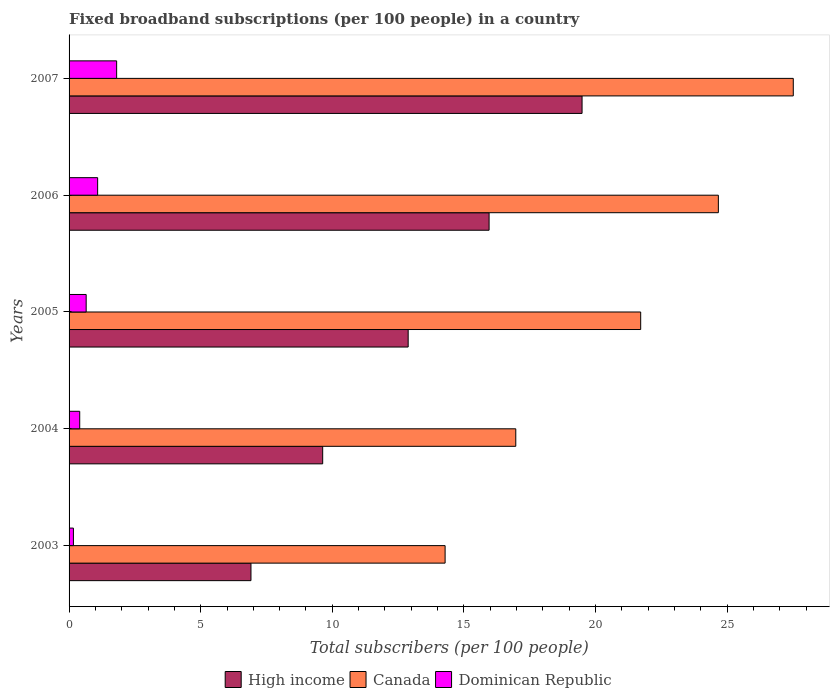How many groups of bars are there?
Provide a short and direct response. 5. Are the number of bars on each tick of the Y-axis equal?
Keep it short and to the point. Yes. What is the label of the 4th group of bars from the top?
Ensure brevity in your answer.  2004. In how many cases, is the number of bars for a given year not equal to the number of legend labels?
Make the answer very short. 0. What is the number of broadband subscriptions in Dominican Republic in 2003?
Provide a short and direct response. 0.17. Across all years, what is the maximum number of broadband subscriptions in Dominican Republic?
Your answer should be very brief. 1.81. Across all years, what is the minimum number of broadband subscriptions in Dominican Republic?
Provide a short and direct response. 0.17. In which year was the number of broadband subscriptions in Canada minimum?
Ensure brevity in your answer.  2003. What is the total number of broadband subscriptions in Canada in the graph?
Offer a very short reply. 105.15. What is the difference between the number of broadband subscriptions in Dominican Republic in 2003 and that in 2006?
Your answer should be compact. -0.92. What is the difference between the number of broadband subscriptions in Canada in 2006 and the number of broadband subscriptions in High income in 2005?
Your answer should be compact. 11.78. What is the average number of broadband subscriptions in Canada per year?
Offer a very short reply. 21.03. In the year 2003, what is the difference between the number of broadband subscriptions in High income and number of broadband subscriptions in Canada?
Your response must be concise. -7.38. In how many years, is the number of broadband subscriptions in High income greater than 19 ?
Give a very brief answer. 1. What is the ratio of the number of broadband subscriptions in Canada in 2003 to that in 2007?
Provide a short and direct response. 0.52. Is the number of broadband subscriptions in Canada in 2003 less than that in 2006?
Give a very brief answer. Yes. Is the difference between the number of broadband subscriptions in High income in 2005 and 2007 greater than the difference between the number of broadband subscriptions in Canada in 2005 and 2007?
Offer a terse response. No. What is the difference between the highest and the second highest number of broadband subscriptions in High income?
Your answer should be very brief. 3.53. What is the difference between the highest and the lowest number of broadband subscriptions in High income?
Keep it short and to the point. 12.58. What does the 2nd bar from the top in 2004 represents?
Provide a short and direct response. Canada. What does the 1st bar from the bottom in 2004 represents?
Provide a short and direct response. High income. Is it the case that in every year, the sum of the number of broadband subscriptions in Canada and number of broadband subscriptions in Dominican Republic is greater than the number of broadband subscriptions in High income?
Ensure brevity in your answer.  Yes. Are all the bars in the graph horizontal?
Your answer should be compact. Yes. How many years are there in the graph?
Your answer should be very brief. 5. What is the difference between two consecutive major ticks on the X-axis?
Offer a very short reply. 5. How many legend labels are there?
Make the answer very short. 3. What is the title of the graph?
Offer a terse response. Fixed broadband subscriptions (per 100 people) in a country. What is the label or title of the X-axis?
Keep it short and to the point. Total subscribers (per 100 people). What is the Total subscribers (per 100 people) of High income in 2003?
Give a very brief answer. 6.91. What is the Total subscribers (per 100 people) in Canada in 2003?
Make the answer very short. 14.29. What is the Total subscribers (per 100 people) in Dominican Republic in 2003?
Keep it short and to the point. 0.17. What is the Total subscribers (per 100 people) in High income in 2004?
Ensure brevity in your answer.  9.63. What is the Total subscribers (per 100 people) of Canada in 2004?
Your answer should be very brief. 16.97. What is the Total subscribers (per 100 people) in Dominican Republic in 2004?
Your answer should be very brief. 0.4. What is the Total subscribers (per 100 people) in High income in 2005?
Ensure brevity in your answer.  12.88. What is the Total subscribers (per 100 people) of Canada in 2005?
Your answer should be very brief. 21.72. What is the Total subscribers (per 100 people) in Dominican Republic in 2005?
Offer a very short reply. 0.65. What is the Total subscribers (per 100 people) of High income in 2006?
Make the answer very short. 15.96. What is the Total subscribers (per 100 people) of Canada in 2006?
Offer a terse response. 24.67. What is the Total subscribers (per 100 people) of Dominican Republic in 2006?
Give a very brief answer. 1.09. What is the Total subscribers (per 100 people) in High income in 2007?
Provide a short and direct response. 19.49. What is the Total subscribers (per 100 people) in Canada in 2007?
Provide a short and direct response. 27.51. What is the Total subscribers (per 100 people) of Dominican Republic in 2007?
Keep it short and to the point. 1.81. Across all years, what is the maximum Total subscribers (per 100 people) of High income?
Make the answer very short. 19.49. Across all years, what is the maximum Total subscribers (per 100 people) in Canada?
Keep it short and to the point. 27.51. Across all years, what is the maximum Total subscribers (per 100 people) of Dominican Republic?
Provide a succinct answer. 1.81. Across all years, what is the minimum Total subscribers (per 100 people) in High income?
Give a very brief answer. 6.91. Across all years, what is the minimum Total subscribers (per 100 people) in Canada?
Ensure brevity in your answer.  14.29. Across all years, what is the minimum Total subscribers (per 100 people) in Dominican Republic?
Keep it short and to the point. 0.17. What is the total Total subscribers (per 100 people) of High income in the graph?
Your answer should be very brief. 64.87. What is the total Total subscribers (per 100 people) of Canada in the graph?
Offer a very short reply. 105.15. What is the total Total subscribers (per 100 people) in Dominican Republic in the graph?
Offer a very short reply. 4.11. What is the difference between the Total subscribers (per 100 people) in High income in 2003 and that in 2004?
Make the answer very short. -2.72. What is the difference between the Total subscribers (per 100 people) of Canada in 2003 and that in 2004?
Provide a succinct answer. -2.69. What is the difference between the Total subscribers (per 100 people) in Dominican Republic in 2003 and that in 2004?
Your response must be concise. -0.24. What is the difference between the Total subscribers (per 100 people) in High income in 2003 and that in 2005?
Offer a terse response. -5.97. What is the difference between the Total subscribers (per 100 people) in Canada in 2003 and that in 2005?
Provide a short and direct response. -7.43. What is the difference between the Total subscribers (per 100 people) in Dominican Republic in 2003 and that in 2005?
Give a very brief answer. -0.48. What is the difference between the Total subscribers (per 100 people) in High income in 2003 and that in 2006?
Ensure brevity in your answer.  -9.05. What is the difference between the Total subscribers (per 100 people) in Canada in 2003 and that in 2006?
Provide a succinct answer. -10.38. What is the difference between the Total subscribers (per 100 people) in Dominican Republic in 2003 and that in 2006?
Ensure brevity in your answer.  -0.92. What is the difference between the Total subscribers (per 100 people) in High income in 2003 and that in 2007?
Make the answer very short. -12.58. What is the difference between the Total subscribers (per 100 people) of Canada in 2003 and that in 2007?
Ensure brevity in your answer.  -13.23. What is the difference between the Total subscribers (per 100 people) of Dominican Republic in 2003 and that in 2007?
Make the answer very short. -1.64. What is the difference between the Total subscribers (per 100 people) of High income in 2004 and that in 2005?
Keep it short and to the point. -3.25. What is the difference between the Total subscribers (per 100 people) of Canada in 2004 and that in 2005?
Ensure brevity in your answer.  -4.75. What is the difference between the Total subscribers (per 100 people) in Dominican Republic in 2004 and that in 2005?
Your response must be concise. -0.24. What is the difference between the Total subscribers (per 100 people) in High income in 2004 and that in 2006?
Keep it short and to the point. -6.32. What is the difference between the Total subscribers (per 100 people) in Canada in 2004 and that in 2006?
Ensure brevity in your answer.  -7.7. What is the difference between the Total subscribers (per 100 people) in Dominican Republic in 2004 and that in 2006?
Make the answer very short. -0.68. What is the difference between the Total subscribers (per 100 people) of High income in 2004 and that in 2007?
Provide a succinct answer. -9.85. What is the difference between the Total subscribers (per 100 people) of Canada in 2004 and that in 2007?
Your response must be concise. -10.54. What is the difference between the Total subscribers (per 100 people) of Dominican Republic in 2004 and that in 2007?
Offer a terse response. -1.4. What is the difference between the Total subscribers (per 100 people) in High income in 2005 and that in 2006?
Make the answer very short. -3.07. What is the difference between the Total subscribers (per 100 people) of Canada in 2005 and that in 2006?
Provide a short and direct response. -2.95. What is the difference between the Total subscribers (per 100 people) of Dominican Republic in 2005 and that in 2006?
Keep it short and to the point. -0.44. What is the difference between the Total subscribers (per 100 people) of High income in 2005 and that in 2007?
Your answer should be very brief. -6.61. What is the difference between the Total subscribers (per 100 people) in Canada in 2005 and that in 2007?
Your answer should be compact. -5.8. What is the difference between the Total subscribers (per 100 people) in Dominican Republic in 2005 and that in 2007?
Offer a terse response. -1.16. What is the difference between the Total subscribers (per 100 people) of High income in 2006 and that in 2007?
Offer a terse response. -3.53. What is the difference between the Total subscribers (per 100 people) of Canada in 2006 and that in 2007?
Provide a short and direct response. -2.85. What is the difference between the Total subscribers (per 100 people) in Dominican Republic in 2006 and that in 2007?
Ensure brevity in your answer.  -0.72. What is the difference between the Total subscribers (per 100 people) of High income in 2003 and the Total subscribers (per 100 people) of Canada in 2004?
Keep it short and to the point. -10.06. What is the difference between the Total subscribers (per 100 people) in High income in 2003 and the Total subscribers (per 100 people) in Dominican Republic in 2004?
Give a very brief answer. 6.51. What is the difference between the Total subscribers (per 100 people) in Canada in 2003 and the Total subscribers (per 100 people) in Dominican Republic in 2004?
Your answer should be compact. 13.88. What is the difference between the Total subscribers (per 100 people) of High income in 2003 and the Total subscribers (per 100 people) of Canada in 2005?
Offer a very short reply. -14.81. What is the difference between the Total subscribers (per 100 people) in High income in 2003 and the Total subscribers (per 100 people) in Dominican Republic in 2005?
Keep it short and to the point. 6.26. What is the difference between the Total subscribers (per 100 people) in Canada in 2003 and the Total subscribers (per 100 people) in Dominican Republic in 2005?
Give a very brief answer. 13.64. What is the difference between the Total subscribers (per 100 people) in High income in 2003 and the Total subscribers (per 100 people) in Canada in 2006?
Provide a short and direct response. -17.76. What is the difference between the Total subscribers (per 100 people) in High income in 2003 and the Total subscribers (per 100 people) in Dominican Republic in 2006?
Your answer should be very brief. 5.82. What is the difference between the Total subscribers (per 100 people) of Canada in 2003 and the Total subscribers (per 100 people) of Dominican Republic in 2006?
Give a very brief answer. 13.2. What is the difference between the Total subscribers (per 100 people) in High income in 2003 and the Total subscribers (per 100 people) in Canada in 2007?
Your answer should be very brief. -20.6. What is the difference between the Total subscribers (per 100 people) in High income in 2003 and the Total subscribers (per 100 people) in Dominican Republic in 2007?
Provide a short and direct response. 5.1. What is the difference between the Total subscribers (per 100 people) in Canada in 2003 and the Total subscribers (per 100 people) in Dominican Republic in 2007?
Give a very brief answer. 12.48. What is the difference between the Total subscribers (per 100 people) of High income in 2004 and the Total subscribers (per 100 people) of Canada in 2005?
Your answer should be very brief. -12.08. What is the difference between the Total subscribers (per 100 people) of High income in 2004 and the Total subscribers (per 100 people) of Dominican Republic in 2005?
Keep it short and to the point. 8.99. What is the difference between the Total subscribers (per 100 people) in Canada in 2004 and the Total subscribers (per 100 people) in Dominican Republic in 2005?
Offer a very short reply. 16.32. What is the difference between the Total subscribers (per 100 people) of High income in 2004 and the Total subscribers (per 100 people) of Canada in 2006?
Offer a very short reply. -15.03. What is the difference between the Total subscribers (per 100 people) of High income in 2004 and the Total subscribers (per 100 people) of Dominican Republic in 2006?
Offer a very short reply. 8.55. What is the difference between the Total subscribers (per 100 people) of Canada in 2004 and the Total subscribers (per 100 people) of Dominican Republic in 2006?
Make the answer very short. 15.89. What is the difference between the Total subscribers (per 100 people) in High income in 2004 and the Total subscribers (per 100 people) in Canada in 2007?
Ensure brevity in your answer.  -17.88. What is the difference between the Total subscribers (per 100 people) of High income in 2004 and the Total subscribers (per 100 people) of Dominican Republic in 2007?
Your answer should be compact. 7.83. What is the difference between the Total subscribers (per 100 people) in Canada in 2004 and the Total subscribers (per 100 people) in Dominican Republic in 2007?
Give a very brief answer. 15.16. What is the difference between the Total subscribers (per 100 people) of High income in 2005 and the Total subscribers (per 100 people) of Canada in 2006?
Offer a very short reply. -11.78. What is the difference between the Total subscribers (per 100 people) of High income in 2005 and the Total subscribers (per 100 people) of Dominican Republic in 2006?
Your response must be concise. 11.8. What is the difference between the Total subscribers (per 100 people) in Canada in 2005 and the Total subscribers (per 100 people) in Dominican Republic in 2006?
Your answer should be compact. 20.63. What is the difference between the Total subscribers (per 100 people) in High income in 2005 and the Total subscribers (per 100 people) in Canada in 2007?
Ensure brevity in your answer.  -14.63. What is the difference between the Total subscribers (per 100 people) in High income in 2005 and the Total subscribers (per 100 people) in Dominican Republic in 2007?
Offer a very short reply. 11.08. What is the difference between the Total subscribers (per 100 people) of Canada in 2005 and the Total subscribers (per 100 people) of Dominican Republic in 2007?
Offer a terse response. 19.91. What is the difference between the Total subscribers (per 100 people) in High income in 2006 and the Total subscribers (per 100 people) in Canada in 2007?
Make the answer very short. -11.56. What is the difference between the Total subscribers (per 100 people) in High income in 2006 and the Total subscribers (per 100 people) in Dominican Republic in 2007?
Make the answer very short. 14.15. What is the difference between the Total subscribers (per 100 people) of Canada in 2006 and the Total subscribers (per 100 people) of Dominican Republic in 2007?
Make the answer very short. 22.86. What is the average Total subscribers (per 100 people) in High income per year?
Your answer should be very brief. 12.97. What is the average Total subscribers (per 100 people) of Canada per year?
Provide a succinct answer. 21.03. What is the average Total subscribers (per 100 people) in Dominican Republic per year?
Your response must be concise. 0.82. In the year 2003, what is the difference between the Total subscribers (per 100 people) in High income and Total subscribers (per 100 people) in Canada?
Make the answer very short. -7.38. In the year 2003, what is the difference between the Total subscribers (per 100 people) in High income and Total subscribers (per 100 people) in Dominican Republic?
Make the answer very short. 6.74. In the year 2003, what is the difference between the Total subscribers (per 100 people) of Canada and Total subscribers (per 100 people) of Dominican Republic?
Give a very brief answer. 14.12. In the year 2004, what is the difference between the Total subscribers (per 100 people) of High income and Total subscribers (per 100 people) of Canada?
Provide a succinct answer. -7.34. In the year 2004, what is the difference between the Total subscribers (per 100 people) of High income and Total subscribers (per 100 people) of Dominican Republic?
Offer a very short reply. 9.23. In the year 2004, what is the difference between the Total subscribers (per 100 people) in Canada and Total subscribers (per 100 people) in Dominican Republic?
Provide a succinct answer. 16.57. In the year 2005, what is the difference between the Total subscribers (per 100 people) in High income and Total subscribers (per 100 people) in Canada?
Provide a succinct answer. -8.83. In the year 2005, what is the difference between the Total subscribers (per 100 people) of High income and Total subscribers (per 100 people) of Dominican Republic?
Give a very brief answer. 12.23. In the year 2005, what is the difference between the Total subscribers (per 100 people) in Canada and Total subscribers (per 100 people) in Dominican Republic?
Your answer should be compact. 21.07. In the year 2006, what is the difference between the Total subscribers (per 100 people) in High income and Total subscribers (per 100 people) in Canada?
Give a very brief answer. -8.71. In the year 2006, what is the difference between the Total subscribers (per 100 people) of High income and Total subscribers (per 100 people) of Dominican Republic?
Your answer should be compact. 14.87. In the year 2006, what is the difference between the Total subscribers (per 100 people) of Canada and Total subscribers (per 100 people) of Dominican Republic?
Make the answer very short. 23.58. In the year 2007, what is the difference between the Total subscribers (per 100 people) of High income and Total subscribers (per 100 people) of Canada?
Make the answer very short. -8.02. In the year 2007, what is the difference between the Total subscribers (per 100 people) of High income and Total subscribers (per 100 people) of Dominican Republic?
Your answer should be compact. 17.68. In the year 2007, what is the difference between the Total subscribers (per 100 people) in Canada and Total subscribers (per 100 people) in Dominican Republic?
Your answer should be compact. 25.71. What is the ratio of the Total subscribers (per 100 people) in High income in 2003 to that in 2004?
Offer a very short reply. 0.72. What is the ratio of the Total subscribers (per 100 people) in Canada in 2003 to that in 2004?
Provide a succinct answer. 0.84. What is the ratio of the Total subscribers (per 100 people) of Dominican Republic in 2003 to that in 2004?
Ensure brevity in your answer.  0.41. What is the ratio of the Total subscribers (per 100 people) in High income in 2003 to that in 2005?
Your answer should be compact. 0.54. What is the ratio of the Total subscribers (per 100 people) in Canada in 2003 to that in 2005?
Your answer should be very brief. 0.66. What is the ratio of the Total subscribers (per 100 people) in Dominican Republic in 2003 to that in 2005?
Your answer should be very brief. 0.25. What is the ratio of the Total subscribers (per 100 people) of High income in 2003 to that in 2006?
Ensure brevity in your answer.  0.43. What is the ratio of the Total subscribers (per 100 people) of Canada in 2003 to that in 2006?
Your answer should be very brief. 0.58. What is the ratio of the Total subscribers (per 100 people) in Dominican Republic in 2003 to that in 2006?
Ensure brevity in your answer.  0.15. What is the ratio of the Total subscribers (per 100 people) of High income in 2003 to that in 2007?
Provide a short and direct response. 0.35. What is the ratio of the Total subscribers (per 100 people) of Canada in 2003 to that in 2007?
Give a very brief answer. 0.52. What is the ratio of the Total subscribers (per 100 people) of Dominican Republic in 2003 to that in 2007?
Ensure brevity in your answer.  0.09. What is the ratio of the Total subscribers (per 100 people) in High income in 2004 to that in 2005?
Your answer should be very brief. 0.75. What is the ratio of the Total subscribers (per 100 people) in Canada in 2004 to that in 2005?
Provide a short and direct response. 0.78. What is the ratio of the Total subscribers (per 100 people) of Dominican Republic in 2004 to that in 2005?
Provide a succinct answer. 0.62. What is the ratio of the Total subscribers (per 100 people) in High income in 2004 to that in 2006?
Make the answer very short. 0.6. What is the ratio of the Total subscribers (per 100 people) of Canada in 2004 to that in 2006?
Provide a succinct answer. 0.69. What is the ratio of the Total subscribers (per 100 people) of Dominican Republic in 2004 to that in 2006?
Your answer should be compact. 0.37. What is the ratio of the Total subscribers (per 100 people) in High income in 2004 to that in 2007?
Your answer should be compact. 0.49. What is the ratio of the Total subscribers (per 100 people) of Canada in 2004 to that in 2007?
Your answer should be very brief. 0.62. What is the ratio of the Total subscribers (per 100 people) of Dominican Republic in 2004 to that in 2007?
Your answer should be compact. 0.22. What is the ratio of the Total subscribers (per 100 people) of High income in 2005 to that in 2006?
Give a very brief answer. 0.81. What is the ratio of the Total subscribers (per 100 people) in Canada in 2005 to that in 2006?
Offer a terse response. 0.88. What is the ratio of the Total subscribers (per 100 people) of Dominican Republic in 2005 to that in 2006?
Ensure brevity in your answer.  0.6. What is the ratio of the Total subscribers (per 100 people) of High income in 2005 to that in 2007?
Offer a very short reply. 0.66. What is the ratio of the Total subscribers (per 100 people) in Canada in 2005 to that in 2007?
Make the answer very short. 0.79. What is the ratio of the Total subscribers (per 100 people) of Dominican Republic in 2005 to that in 2007?
Your response must be concise. 0.36. What is the ratio of the Total subscribers (per 100 people) of High income in 2006 to that in 2007?
Provide a succinct answer. 0.82. What is the ratio of the Total subscribers (per 100 people) in Canada in 2006 to that in 2007?
Offer a very short reply. 0.9. What is the ratio of the Total subscribers (per 100 people) in Dominican Republic in 2006 to that in 2007?
Your response must be concise. 0.6. What is the difference between the highest and the second highest Total subscribers (per 100 people) in High income?
Provide a succinct answer. 3.53. What is the difference between the highest and the second highest Total subscribers (per 100 people) of Canada?
Your answer should be compact. 2.85. What is the difference between the highest and the second highest Total subscribers (per 100 people) of Dominican Republic?
Your response must be concise. 0.72. What is the difference between the highest and the lowest Total subscribers (per 100 people) of High income?
Provide a succinct answer. 12.58. What is the difference between the highest and the lowest Total subscribers (per 100 people) of Canada?
Offer a terse response. 13.23. What is the difference between the highest and the lowest Total subscribers (per 100 people) in Dominican Republic?
Offer a very short reply. 1.64. 